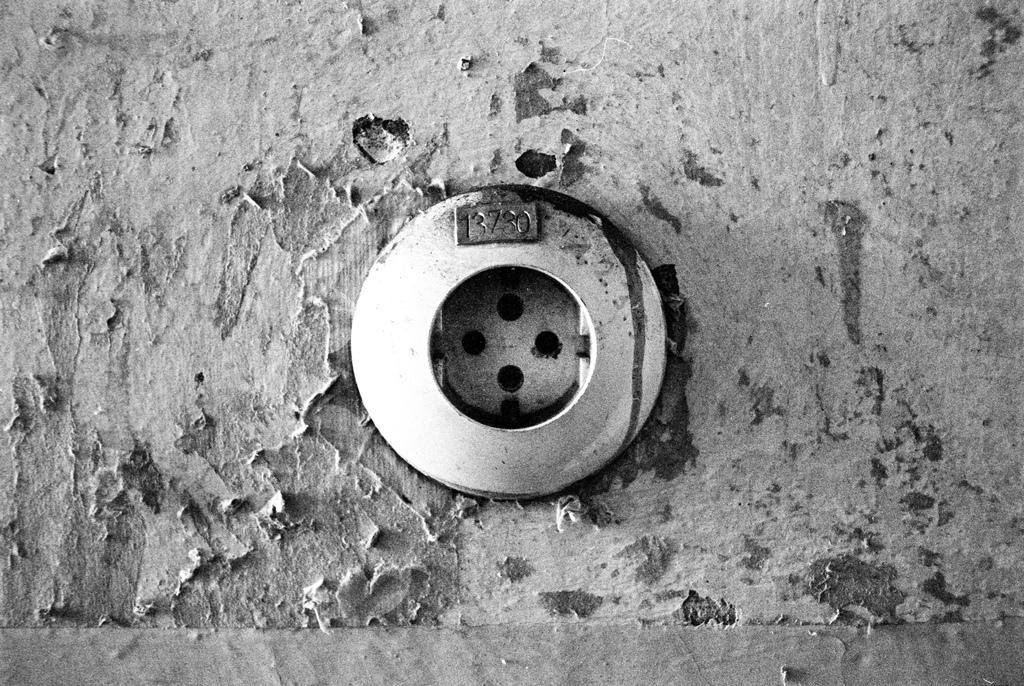<image>
Present a compact description of the photo's key features. the number 3730 at the top of a circular item 